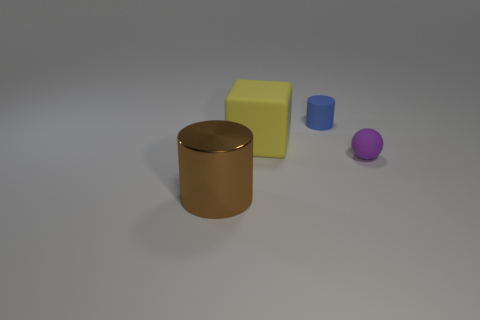Does the sphere have the same color as the cylinder that is in front of the yellow block?
Your answer should be compact. No. The block is what color?
Provide a short and direct response. Yellow. Are there any other things that have the same shape as the big brown object?
Offer a terse response. Yes. There is a small rubber object that is the same shape as the big brown object; what is its color?
Keep it short and to the point. Blue. Does the purple object have the same shape as the large brown metal thing?
Offer a terse response. No. What number of cylinders are either big red metallic objects or big things?
Provide a succinct answer. 1. What is the color of the other small object that is made of the same material as the tiny blue object?
Make the answer very short. Purple. There is a cylinder that is behind the purple matte object; does it have the same size as the brown metallic thing?
Provide a succinct answer. No. Do the big yellow cube and the cylinder that is behind the large brown shiny object have the same material?
Make the answer very short. Yes. The cylinder behind the big metal cylinder is what color?
Ensure brevity in your answer.  Blue. 